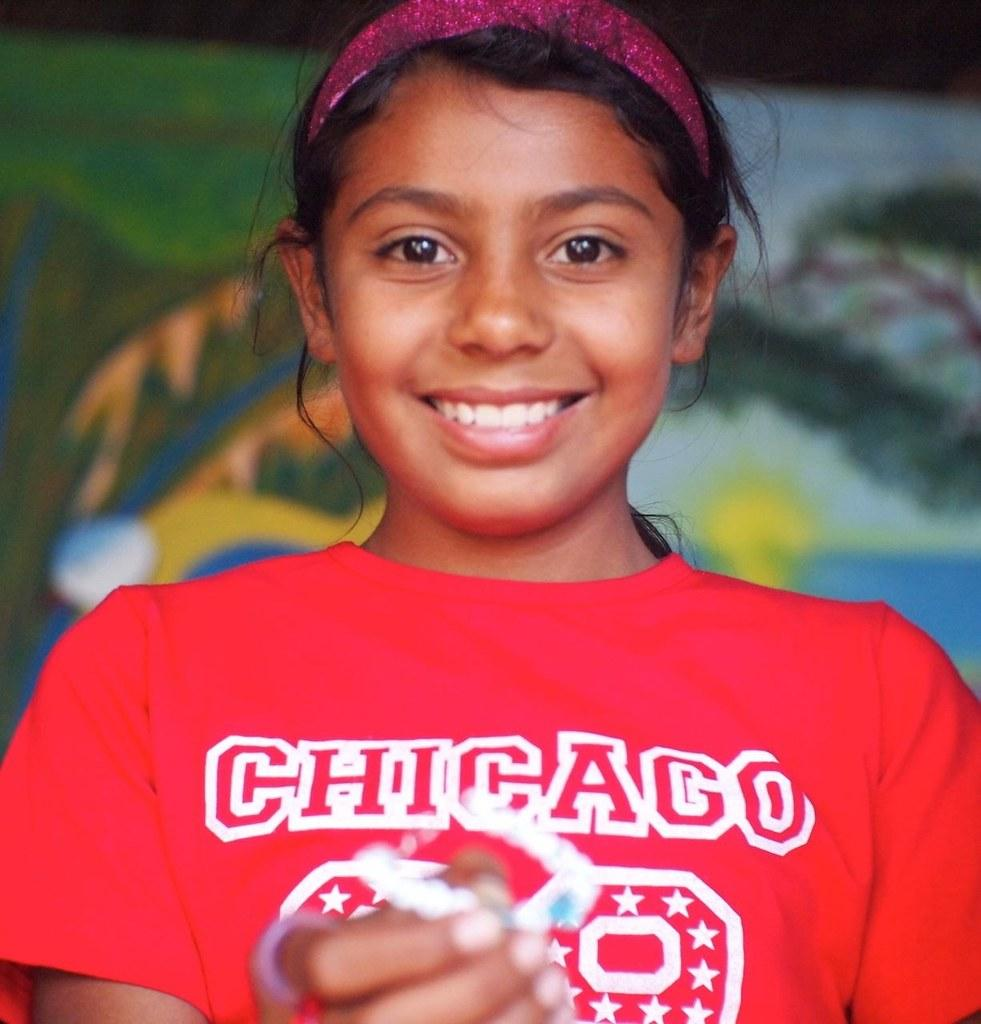Who is the main subject in the image? There is a girl in the image. What is the girl wearing? The girl is wearing a red t-shirt. What is the girl holding in the image? The girl is holding an object. What is the girl's facial expression? The girl is smiling. Can you describe the background of the image? The background of the image is blurred, and there is a painting visible. What type of marble is the girl playing with in the image? There is no marble present in the image. Is the girl holding a rifle in the image? No, the girl is not holding a rifle in the image. 